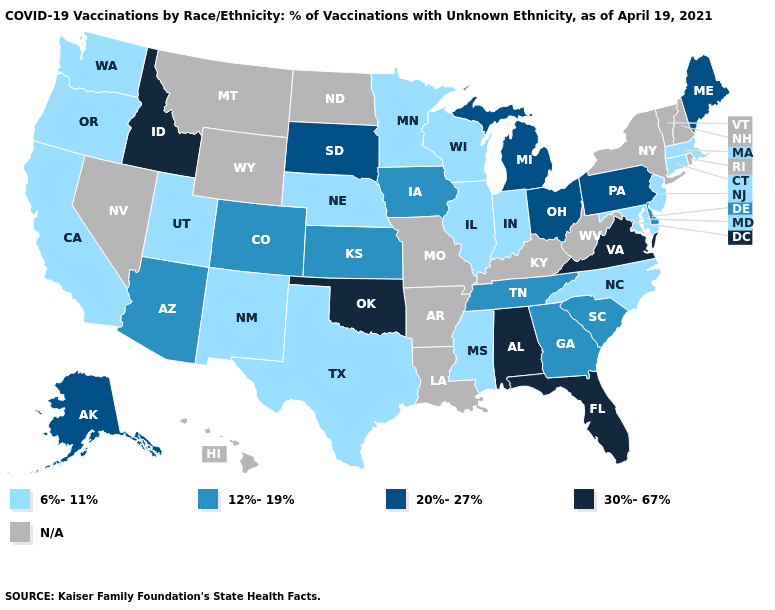What is the value of Oregon?
Concise answer only. 6%-11%. Does Maryland have the lowest value in the South?
Quick response, please. Yes. Does Virginia have the highest value in the USA?
Be succinct. Yes. Name the states that have a value in the range 6%-11%?
Short answer required. California, Connecticut, Illinois, Indiana, Maryland, Massachusetts, Minnesota, Mississippi, Nebraska, New Jersey, New Mexico, North Carolina, Oregon, Texas, Utah, Washington, Wisconsin. What is the highest value in states that border Illinois?
Answer briefly. 12%-19%. What is the value of Vermont?
Concise answer only. N/A. How many symbols are there in the legend?
Give a very brief answer. 5. Name the states that have a value in the range 30%-67%?
Short answer required. Alabama, Florida, Idaho, Oklahoma, Virginia. Does Idaho have the highest value in the USA?
Write a very short answer. Yes. Is the legend a continuous bar?
Write a very short answer. No. Name the states that have a value in the range 30%-67%?
Be succinct. Alabama, Florida, Idaho, Oklahoma, Virginia. Does the map have missing data?
Short answer required. Yes. Name the states that have a value in the range N/A?
Be succinct. Arkansas, Hawaii, Kentucky, Louisiana, Missouri, Montana, Nevada, New Hampshire, New York, North Dakota, Rhode Island, Vermont, West Virginia, Wyoming. What is the lowest value in the USA?
Keep it brief. 6%-11%. 